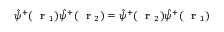Convert formula to latex. <formula><loc_0><loc_0><loc_500><loc_500>\hat { \psi } ^ { + } ( r _ { 1 } ) \hat { \psi } ^ { + } ( r _ { 2 } ) = \hat { \psi } ^ { + } ( r _ { 2 } ) \hat { \psi } ^ { + } ( r _ { 1 } )</formula> 